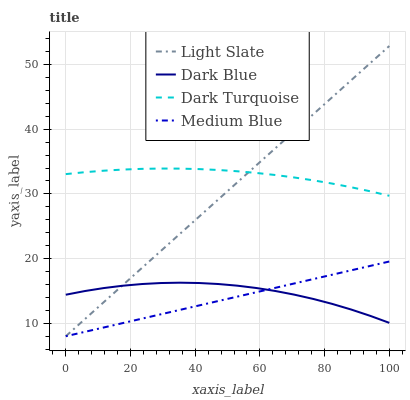Does Medium Blue have the minimum area under the curve?
Answer yes or no. Yes. Does Dark Turquoise have the maximum area under the curve?
Answer yes or no. Yes. Does Dark Blue have the minimum area under the curve?
Answer yes or no. No. Does Dark Blue have the maximum area under the curve?
Answer yes or no. No. Is Medium Blue the smoothest?
Answer yes or no. Yes. Is Dark Blue the roughest?
Answer yes or no. Yes. Is Dark Blue the smoothest?
Answer yes or no. No. Is Medium Blue the roughest?
Answer yes or no. No. Does Dark Blue have the lowest value?
Answer yes or no. No. Does Light Slate have the highest value?
Answer yes or no. Yes. Does Medium Blue have the highest value?
Answer yes or no. No. Is Dark Blue less than Dark Turquoise?
Answer yes or no. Yes. Is Dark Turquoise greater than Dark Blue?
Answer yes or no. Yes. Does Dark Blue intersect Dark Turquoise?
Answer yes or no. No. 